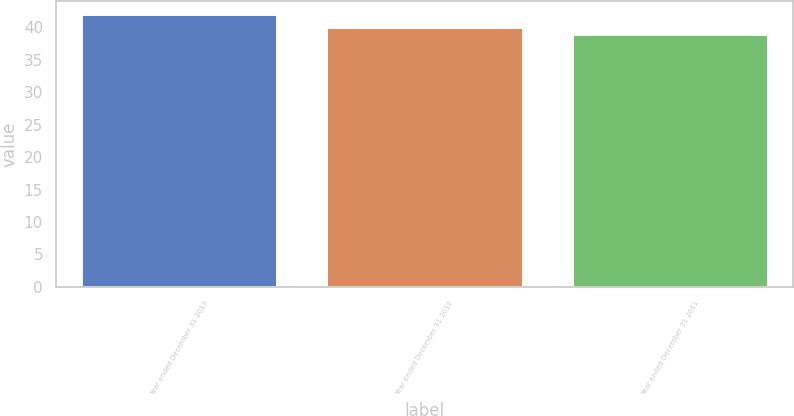Convert chart. <chart><loc_0><loc_0><loc_500><loc_500><bar_chart><fcel>Year ended December 31 2013<fcel>Year ended December 31 2012<fcel>Year ended December 31 2011<nl><fcel>42<fcel>40<fcel>39<nl></chart> 